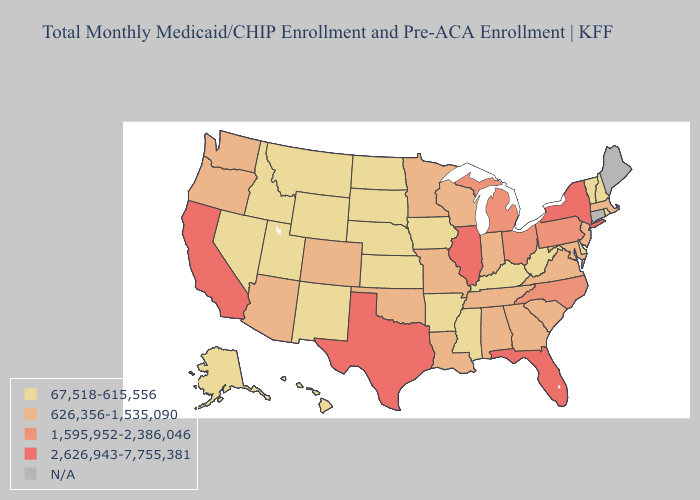Which states have the lowest value in the USA?
Concise answer only. Alaska, Arkansas, Delaware, Hawaii, Idaho, Iowa, Kansas, Kentucky, Mississippi, Montana, Nebraska, Nevada, New Hampshire, New Mexico, North Dakota, Rhode Island, South Dakota, Utah, Vermont, West Virginia, Wyoming. What is the lowest value in the Northeast?
Short answer required. 67,518-615,556. Name the states that have a value in the range 2,626,943-7,755,381?
Quick response, please. California, Florida, Illinois, New York, Texas. Does California have the highest value in the USA?
Keep it brief. Yes. Among the states that border Arkansas , does Mississippi have the highest value?
Give a very brief answer. No. Among the states that border Michigan , does Indiana have the lowest value?
Write a very short answer. Yes. What is the lowest value in the USA?
Give a very brief answer. 67,518-615,556. Does Oregon have the lowest value in the USA?
Be succinct. No. Does the map have missing data?
Write a very short answer. Yes. Among the states that border Indiana , which have the lowest value?
Short answer required. Kentucky. What is the value of Georgia?
Concise answer only. 626,356-1,535,090. How many symbols are there in the legend?
Quick response, please. 5. Is the legend a continuous bar?
Write a very short answer. No. Which states have the highest value in the USA?
Give a very brief answer. California, Florida, Illinois, New York, Texas. 